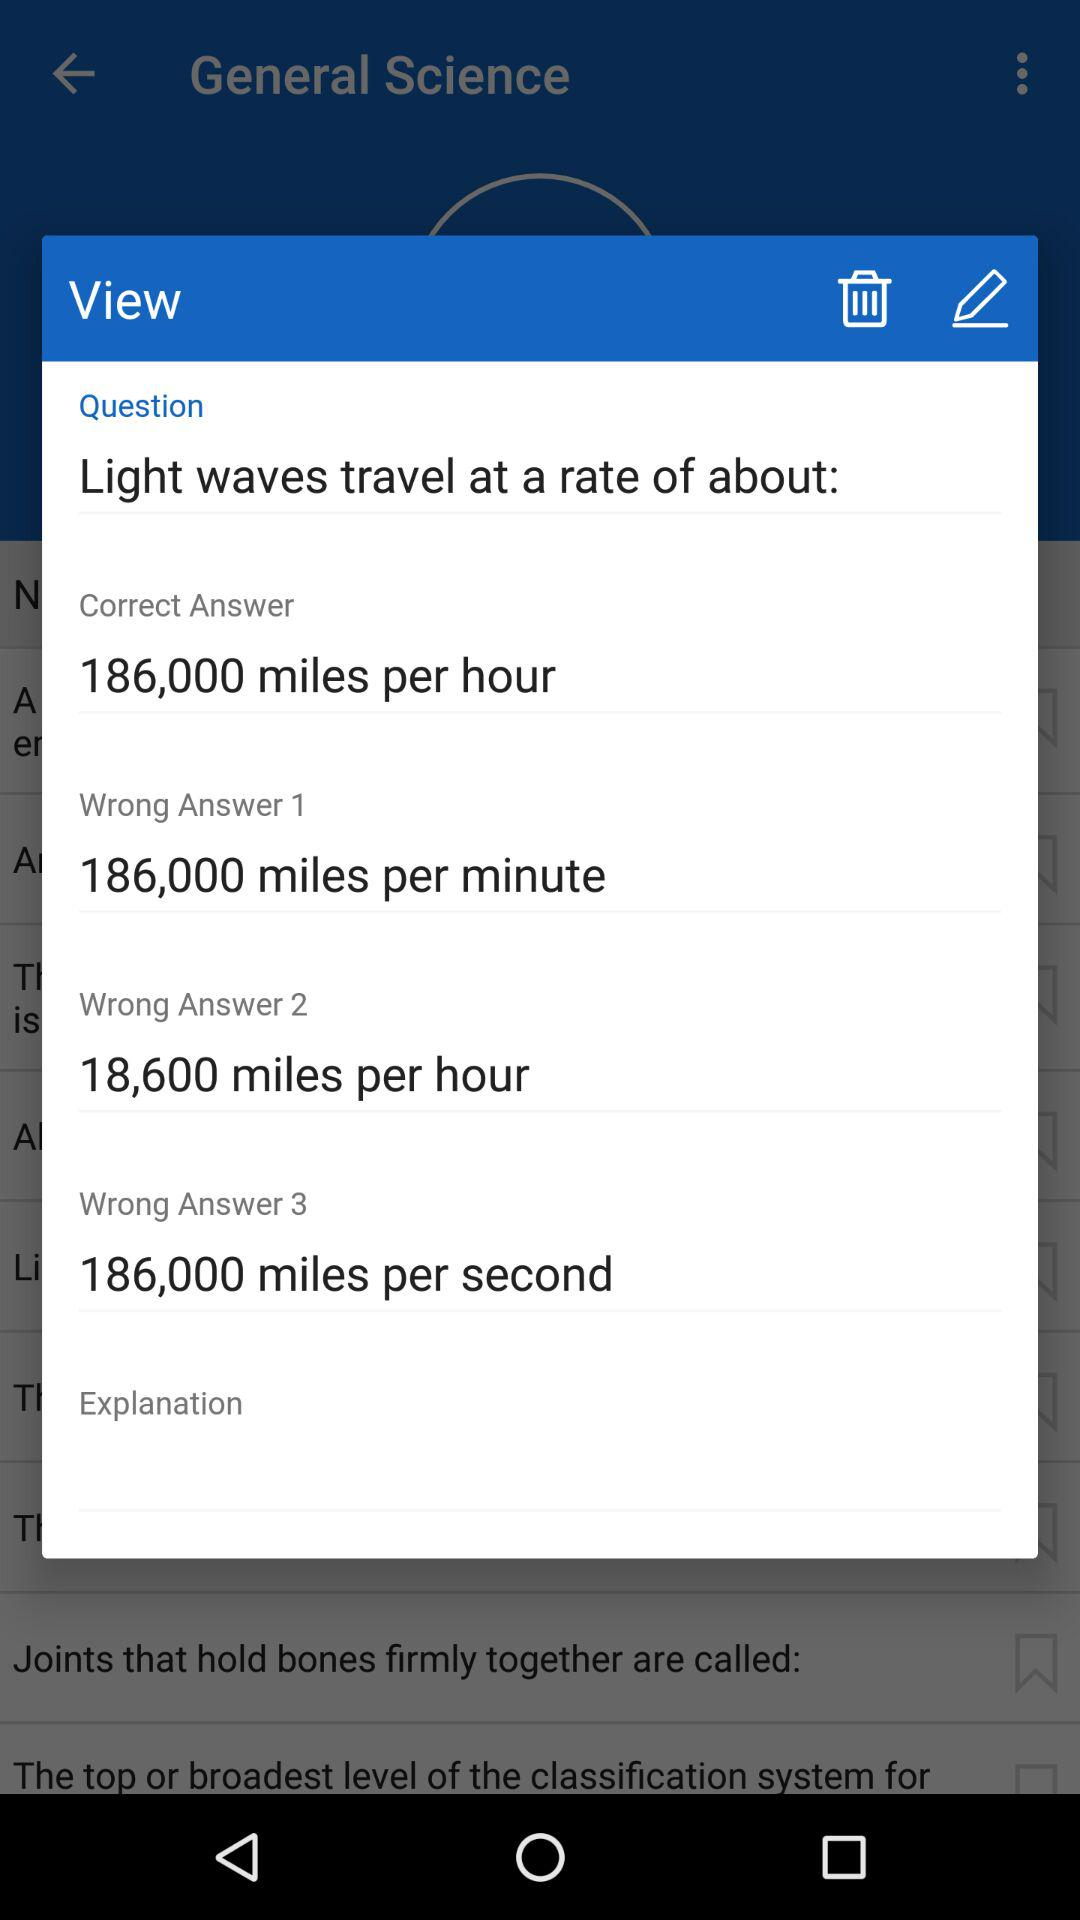How many wrong answers are there in total?
Answer the question using a single word or phrase. 3 